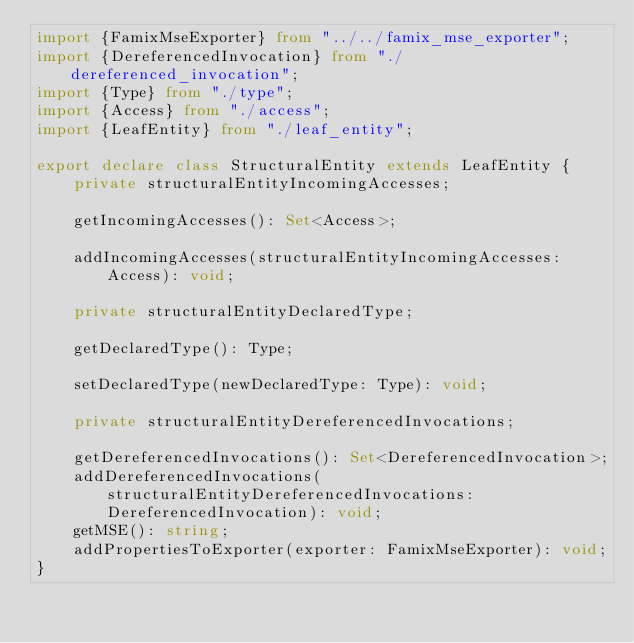<code> <loc_0><loc_0><loc_500><loc_500><_TypeScript_>import {FamixMseExporter} from "../../famix_mse_exporter";
import {DereferencedInvocation} from "./dereferenced_invocation";
import {Type} from "./type";
import {Access} from "./access";
import {LeafEntity} from "./leaf_entity";

export declare class StructuralEntity extends LeafEntity {
    private structuralEntityIncomingAccesses;

    getIncomingAccesses(): Set<Access>;

    addIncomingAccesses(structuralEntityIncomingAccesses: Access): void;

    private structuralEntityDeclaredType;

    getDeclaredType(): Type;

    setDeclaredType(newDeclaredType: Type): void;

    private structuralEntityDereferencedInvocations;

    getDereferencedInvocations(): Set<DereferencedInvocation>;
    addDereferencedInvocations(structuralEntityDereferencedInvocations: DereferencedInvocation): void;
    getMSE(): string;
    addPropertiesToExporter(exporter: FamixMseExporter): void;
}
</code> 